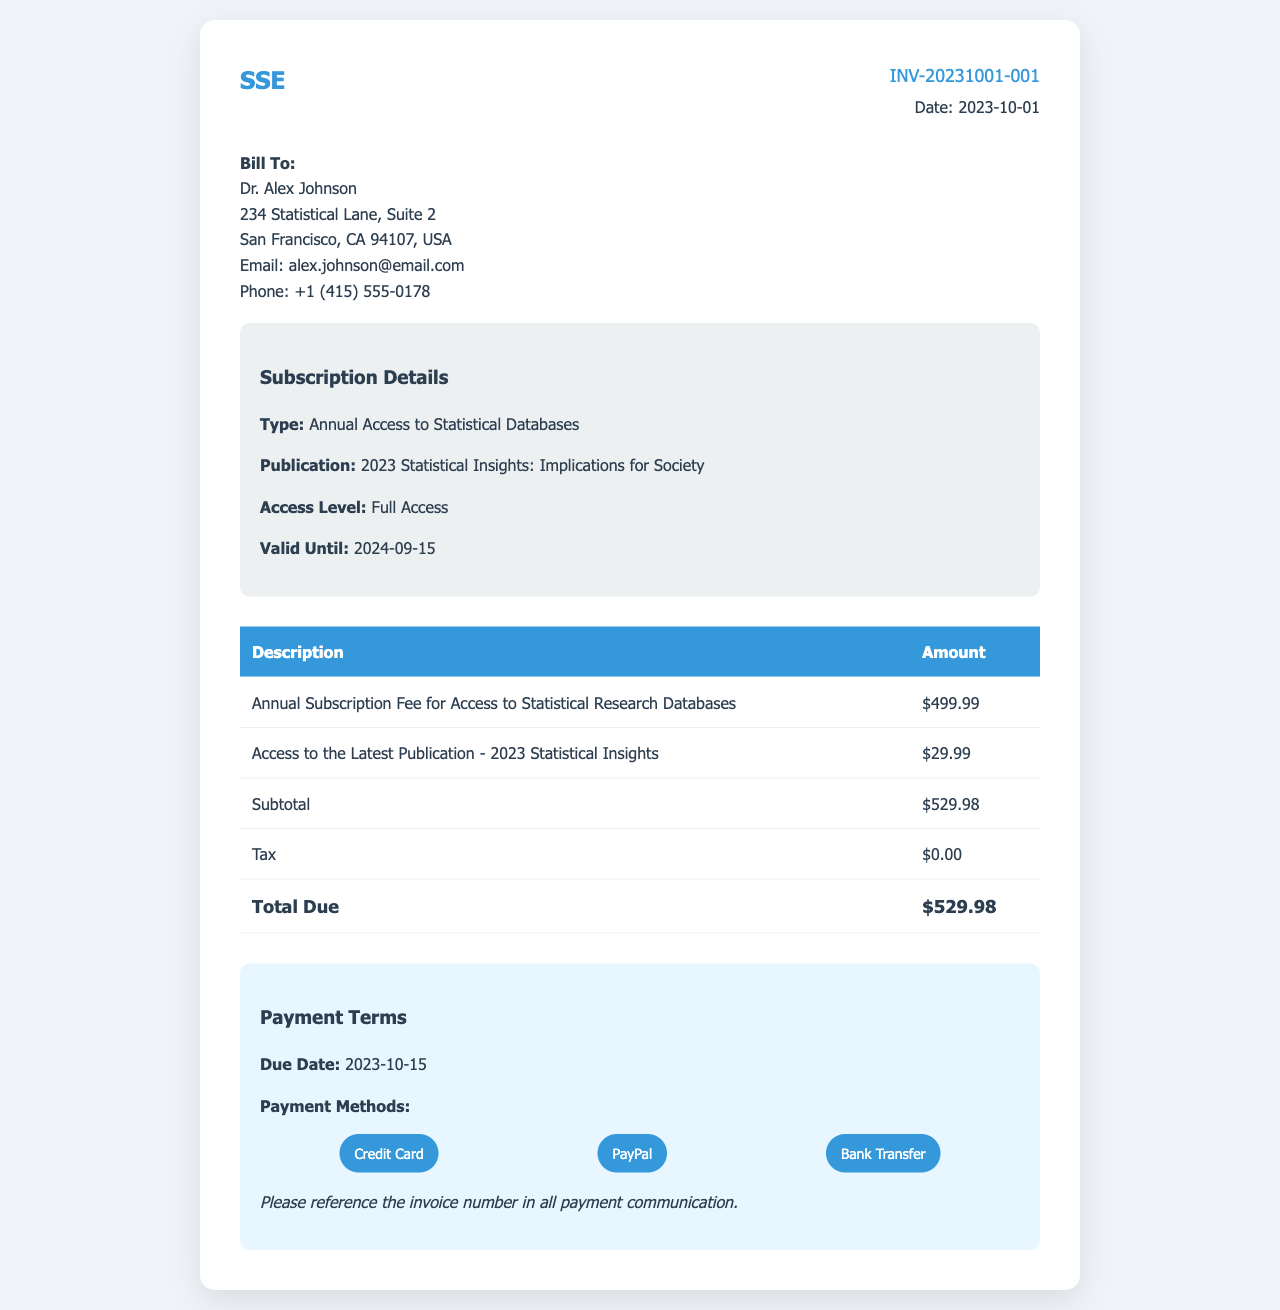What is the invoice number? The invoice number is stated in the invoice details section, identifying this specific transaction.
Answer: INV-20231001-001 Who is the invoice billed to? The "Bill To" section provides the name of the individual or organization being invoiced.
Answer: Dr. Alex Johnson What is the total amount due? The total amount due is calculated by summing the subtotal and tax present in the invoice.
Answer: $529.98 When is the payment due? The due date for the payment is explicitly mentioned under the payment terms section.
Answer: 2023-10-15 What is included in the subscription details? The subscription details overview provides specific information about the type of subscription and the publication access being granted.
Answer: Annual Access to Statistical Databases What method of payment is mentioned? The document lists various payment methods available for settling the invoice.
Answer: Credit Card, PayPal, Bank Transfer How much is the annual subscription fee? The document specifies the fee associated with the annual subscription for accessing databases, which is listed separately.
Answer: $499.99 What is the publication title? The title of the latest publication included in the subscription is mentioned in the subscription section.
Answer: 2023 Statistical Insights: Implications for Society How long is the access valid until? The valid date until which access is granted is explicitly stated in the subscription details.
Answer: 2024-09-15 